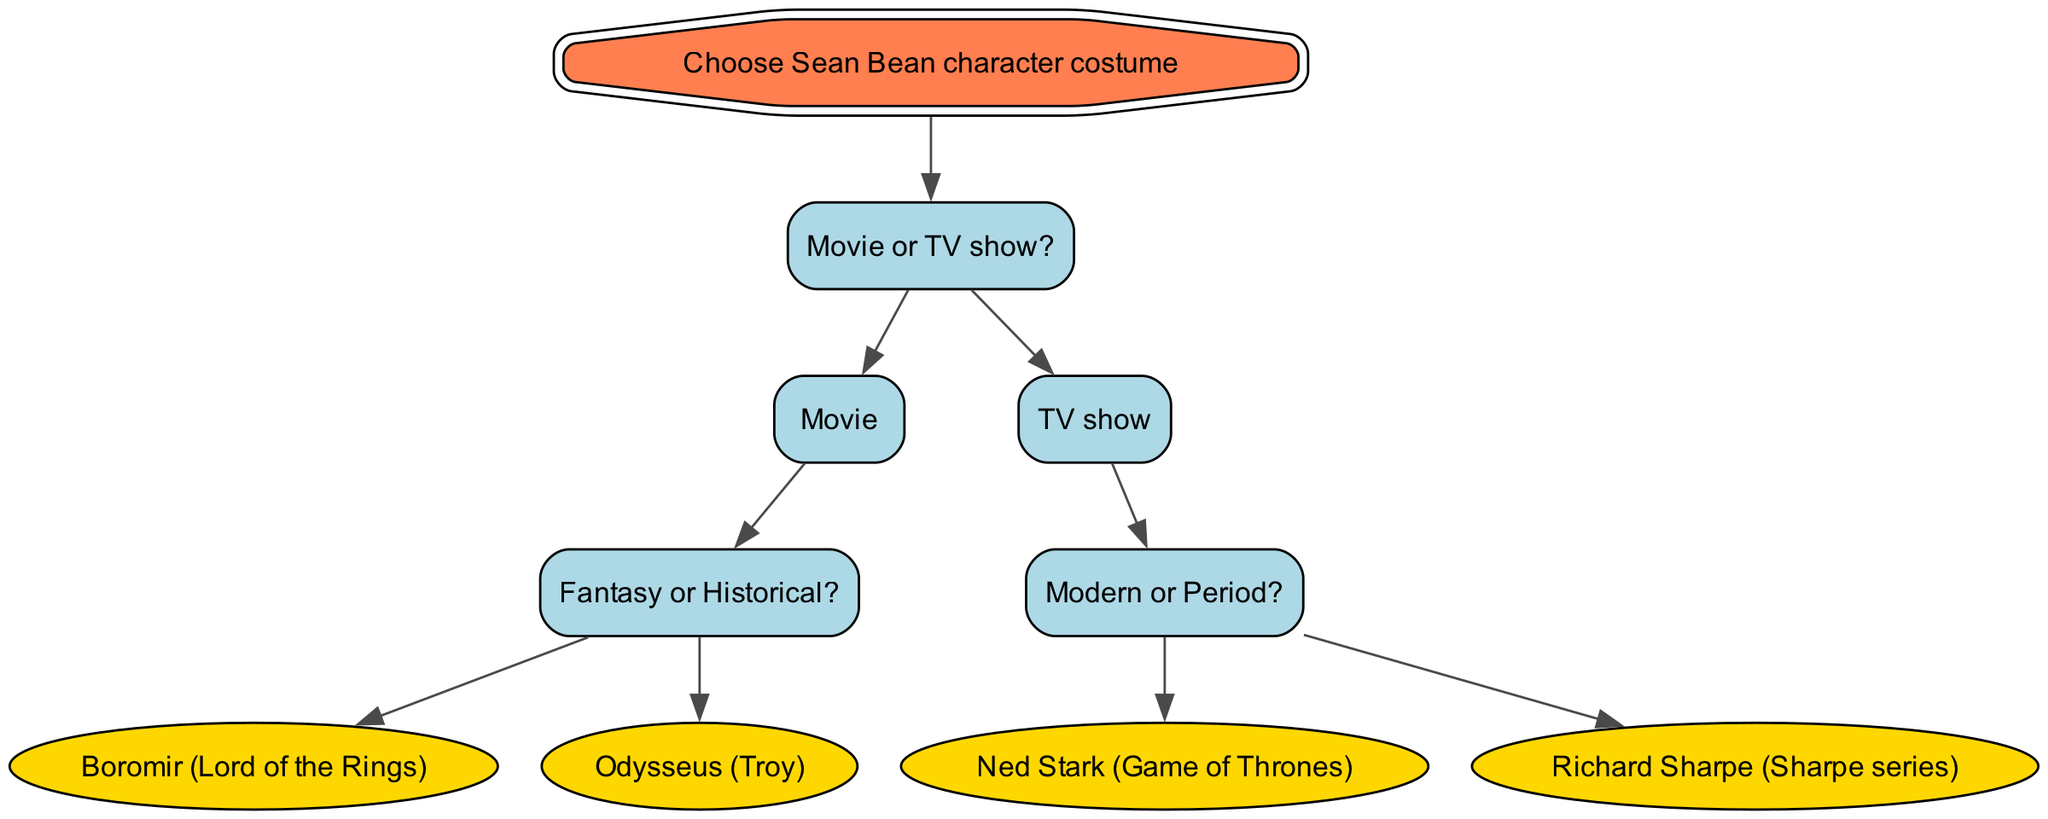What is the root of the decision tree? The root of the decision tree is the starting point for making choices, which is "Choose Sean Bean character costume."
Answer: Choose Sean Bean character costume How many main paths are there from the root? The diagram has two main paths that split at the "Movie or TV show?" node, leading to either "Movie" or "TV show."
Answer: 2 What costume should you choose if you prefer a fantasy character? If you select “Movie” and then choose "Fantasy," the resulting costume is "Boromir" from "Lord of the Rings."
Answer: Boromir (Lord of the Rings) Which character is associated with a historical setting? Following the path through the “Movie” to "Historical" will lead you to “Odysseus” from "Troy."
Answer: Odysseus (Troy) If you choose "TV show" and prefer a period character, which costume should you wear? After selecting "TV show" and then choosing "Period," you would wear "Richard Sharpe" from the "Sharpe series."
Answer: Richard Sharpe (Sharpe series) What character do you get by selecting a modern TV show? By choosing the "TV show" option followed by "Modern," you end up with "Ned Stark" from "Game of Thrones."
Answer: Ned Stark (Game of Thrones) How many character outcomes are there based on the choices provided? The decision tree outlines four distinct character outcomes based on specific choices made at different nodes.
Answer: 4 What is the first decision you need to make? The first decision point in the diagram is whether to choose a "Movie" or a "TV show."
Answer: Movie or TV show What type of questions does this decision tree specifically help with? This decision tree is designed to help answer questions regarding costume selection based on Sean Bean's character roles in either movies or TV shows.
Answer: Costume selection 